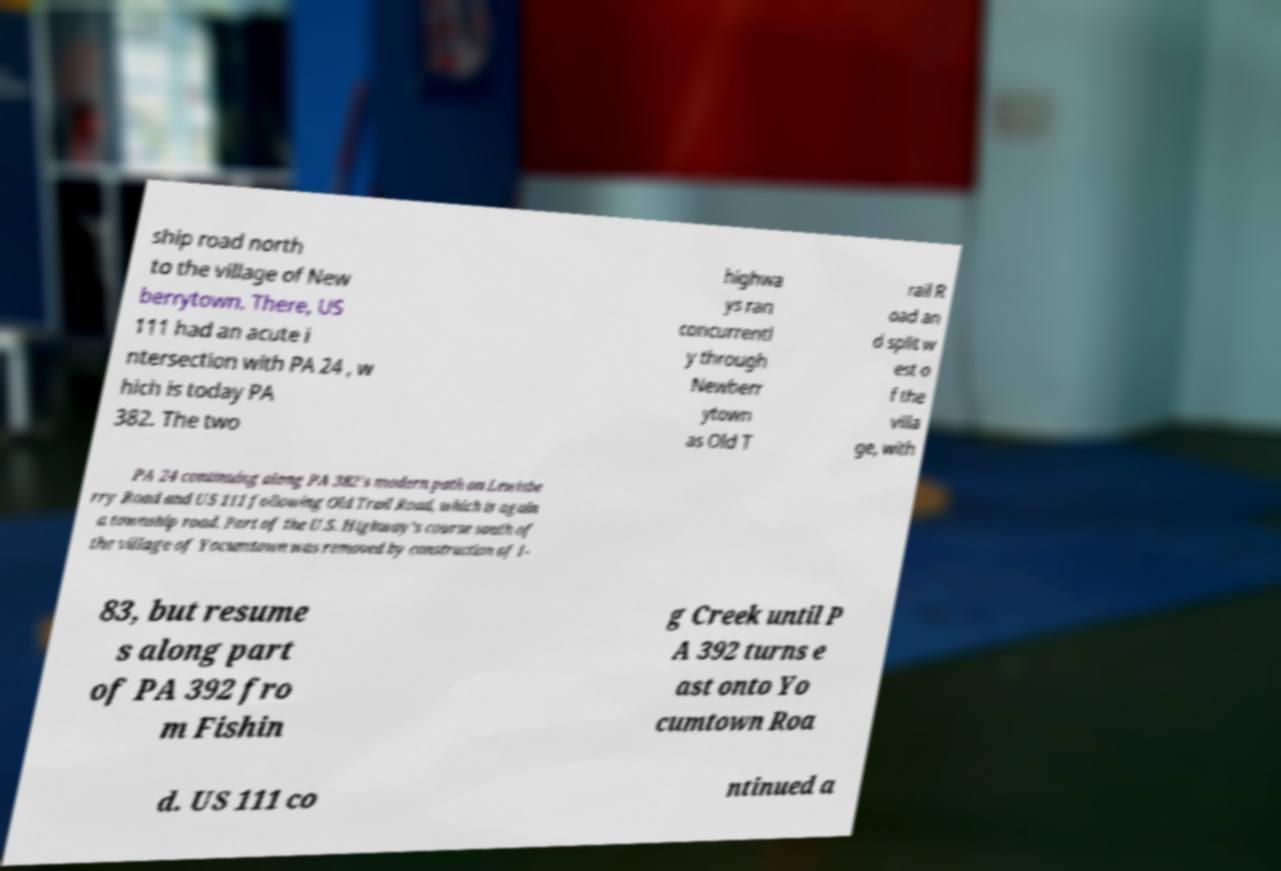Can you read and provide the text displayed in the image?This photo seems to have some interesting text. Can you extract and type it out for me? ship road north to the village of New berrytown. There, US 111 had an acute i ntersection with PA 24 , w hich is today PA 382. The two highwa ys ran concurrentl y through Newberr ytown as Old T rail R oad an d split w est o f the villa ge, with PA 24 continuing along PA 382's modern path on Lewisbe rry Road and US 111 following Old Trail Road, which is again a township road. Part of the U.S. Highway's course south of the village of Yocumtown was removed by construction of I- 83, but resume s along part of PA 392 fro m Fishin g Creek until P A 392 turns e ast onto Yo cumtown Roa d. US 111 co ntinued a 